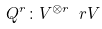Convert formula to latex. <formula><loc_0><loc_0><loc_500><loc_500>Q ^ { r } \colon V ^ { \otimes r } \ r V</formula> 